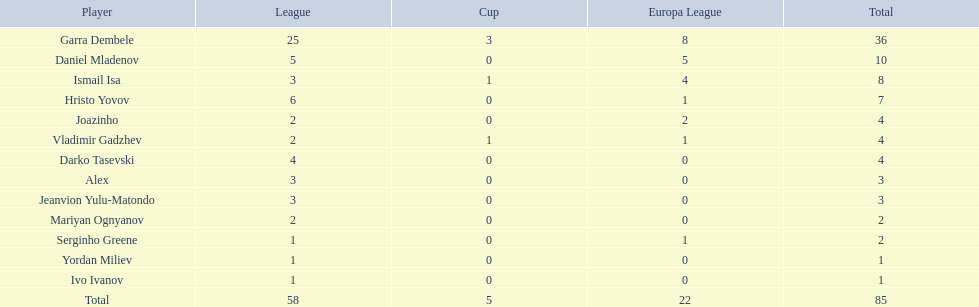What players did not score in all 3 competitions? Daniel Mladenov, Hristo Yovov, Joazinho, Darko Tasevski, Alex, Jeanvion Yulu-Matondo, Mariyan Ognyanov, Serginho Greene, Yordan Miliev, Ivo Ivanov. Which of those did not have total more then 5? Darko Tasevski, Alex, Jeanvion Yulu-Matondo, Mariyan Ognyanov, Serginho Greene, Yordan Miliev, Ivo Ivanov. Which ones scored more then 1 total? Darko Tasevski, Alex, Jeanvion Yulu-Matondo, Mariyan Ognyanov. Which of these player had the lease league points? Mariyan Ognyanov. 